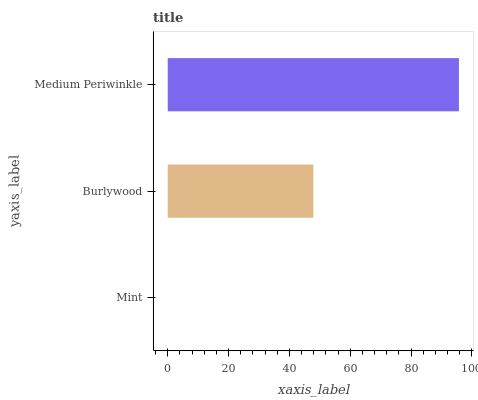Is Mint the minimum?
Answer yes or no. Yes. Is Medium Periwinkle the maximum?
Answer yes or no. Yes. Is Burlywood the minimum?
Answer yes or no. No. Is Burlywood the maximum?
Answer yes or no. No. Is Burlywood greater than Mint?
Answer yes or no. Yes. Is Mint less than Burlywood?
Answer yes or no. Yes. Is Mint greater than Burlywood?
Answer yes or no. No. Is Burlywood less than Mint?
Answer yes or no. No. Is Burlywood the high median?
Answer yes or no. Yes. Is Burlywood the low median?
Answer yes or no. Yes. Is Medium Periwinkle the high median?
Answer yes or no. No. Is Medium Periwinkle the low median?
Answer yes or no. No. 